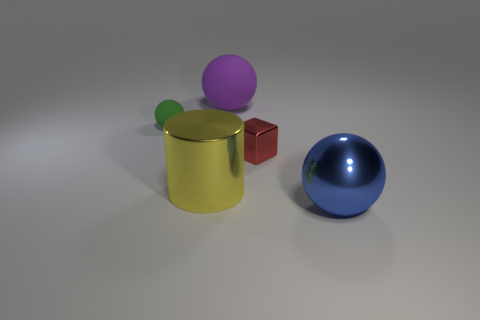There is a green matte sphere; is its size the same as the sphere that is in front of the large yellow shiny object?
Offer a very short reply. No. What shape is the rubber object that is on the left side of the ball that is behind the tiny sphere?
Your response must be concise. Sphere. Are there fewer large spheres behind the large yellow metal cylinder than small yellow shiny cubes?
Provide a short and direct response. No. How many yellow objects have the same size as the blue metal sphere?
Keep it short and to the point. 1. There is a big thing that is behind the red metal thing; what shape is it?
Your answer should be compact. Sphere. Is the number of large purple balls less than the number of brown metal cylinders?
Give a very brief answer. No. Are there any other things of the same color as the large metallic cylinder?
Keep it short and to the point. No. What size is the metallic object that is behind the large cylinder?
Your response must be concise. Small. Is the number of brown rubber cubes greater than the number of big yellow cylinders?
Provide a short and direct response. No. What material is the cylinder?
Make the answer very short. Metal. 